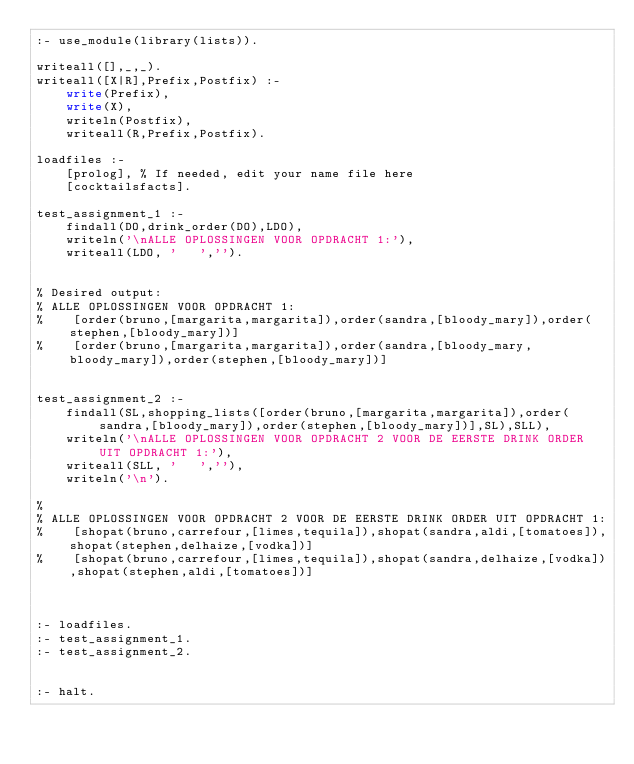Convert code to text. <code><loc_0><loc_0><loc_500><loc_500><_Perl_>:- use_module(library(lists)).

writeall([],_,_).
writeall([X|R],Prefix,Postfix) :-
    write(Prefix),
    write(X),
    writeln(Postfix),
    writeall(R,Prefix,Postfix).

loadfiles :-
    [prolog], % If needed, edit your name file here
    [cocktailsfacts].

test_assignment_1 :-
    findall(DO,drink_order(DO),LDO),
    writeln('\nALLE OPLOSSINGEN VOOR OPDRACHT 1:'),
    writeall(LDO, '   ','').


% Desired output:
% ALLE OPLOSSINGEN VOOR OPDRACHT 1:
%    [order(bruno,[margarita,margarita]),order(sandra,[bloody_mary]),order(stephen,[bloody_mary])]
%    [order(bruno,[margarita,margarita]),order(sandra,[bloody_mary,bloody_mary]),order(stephen,[bloody_mary])]


test_assignment_2 :-
    findall(SL,shopping_lists([order(bruno,[margarita,margarita]),order(sandra,[bloody_mary]),order(stephen,[bloody_mary])],SL),SLL),
    writeln('\nALLE OPLOSSINGEN VOOR OPDRACHT 2 VOOR DE EERSTE DRINK ORDER UIT OPDRACHT 1:'),
    writeall(SLL, '   ',''),
    writeln('\n').

% 
% ALLE OPLOSSINGEN VOOR OPDRACHT 2 VOOR DE EERSTE DRINK ORDER UIT OPDRACHT 1:
%    [shopat(bruno,carrefour,[limes,tequila]),shopat(sandra,aldi,[tomatoes]),shopat(stephen,delhaize,[vodka])]
%    [shopat(bruno,carrefour,[limes,tequila]),shopat(sandra,delhaize,[vodka]),shopat(stephen,aldi,[tomatoes])]



:- loadfiles.
:- test_assignment_1.
:- test_assignment_2.


:- halt.</code> 